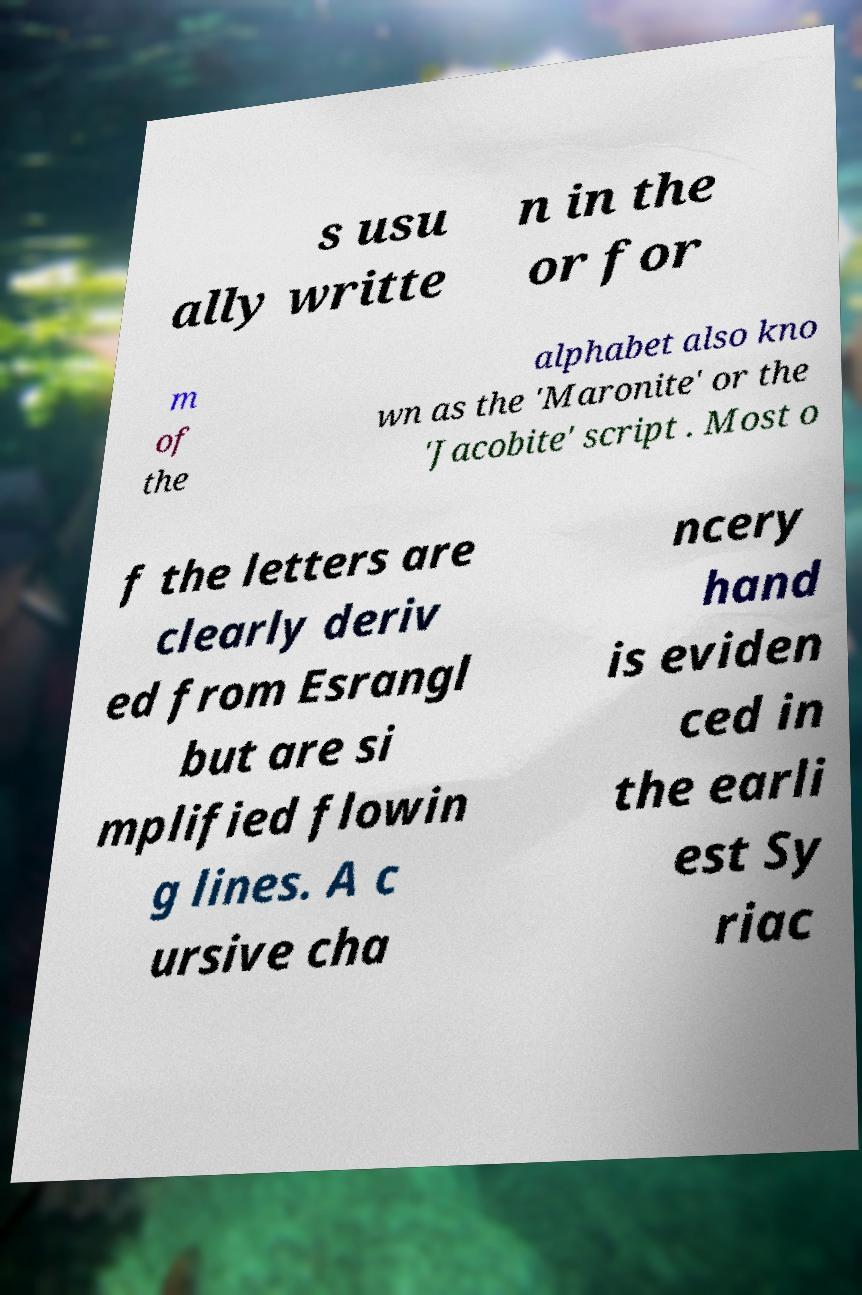Could you assist in decoding the text presented in this image and type it out clearly? s usu ally writte n in the or for m of the alphabet also kno wn as the 'Maronite' or the 'Jacobite' script . Most o f the letters are clearly deriv ed from Esrangl but are si mplified flowin g lines. A c ursive cha ncery hand is eviden ced in the earli est Sy riac 